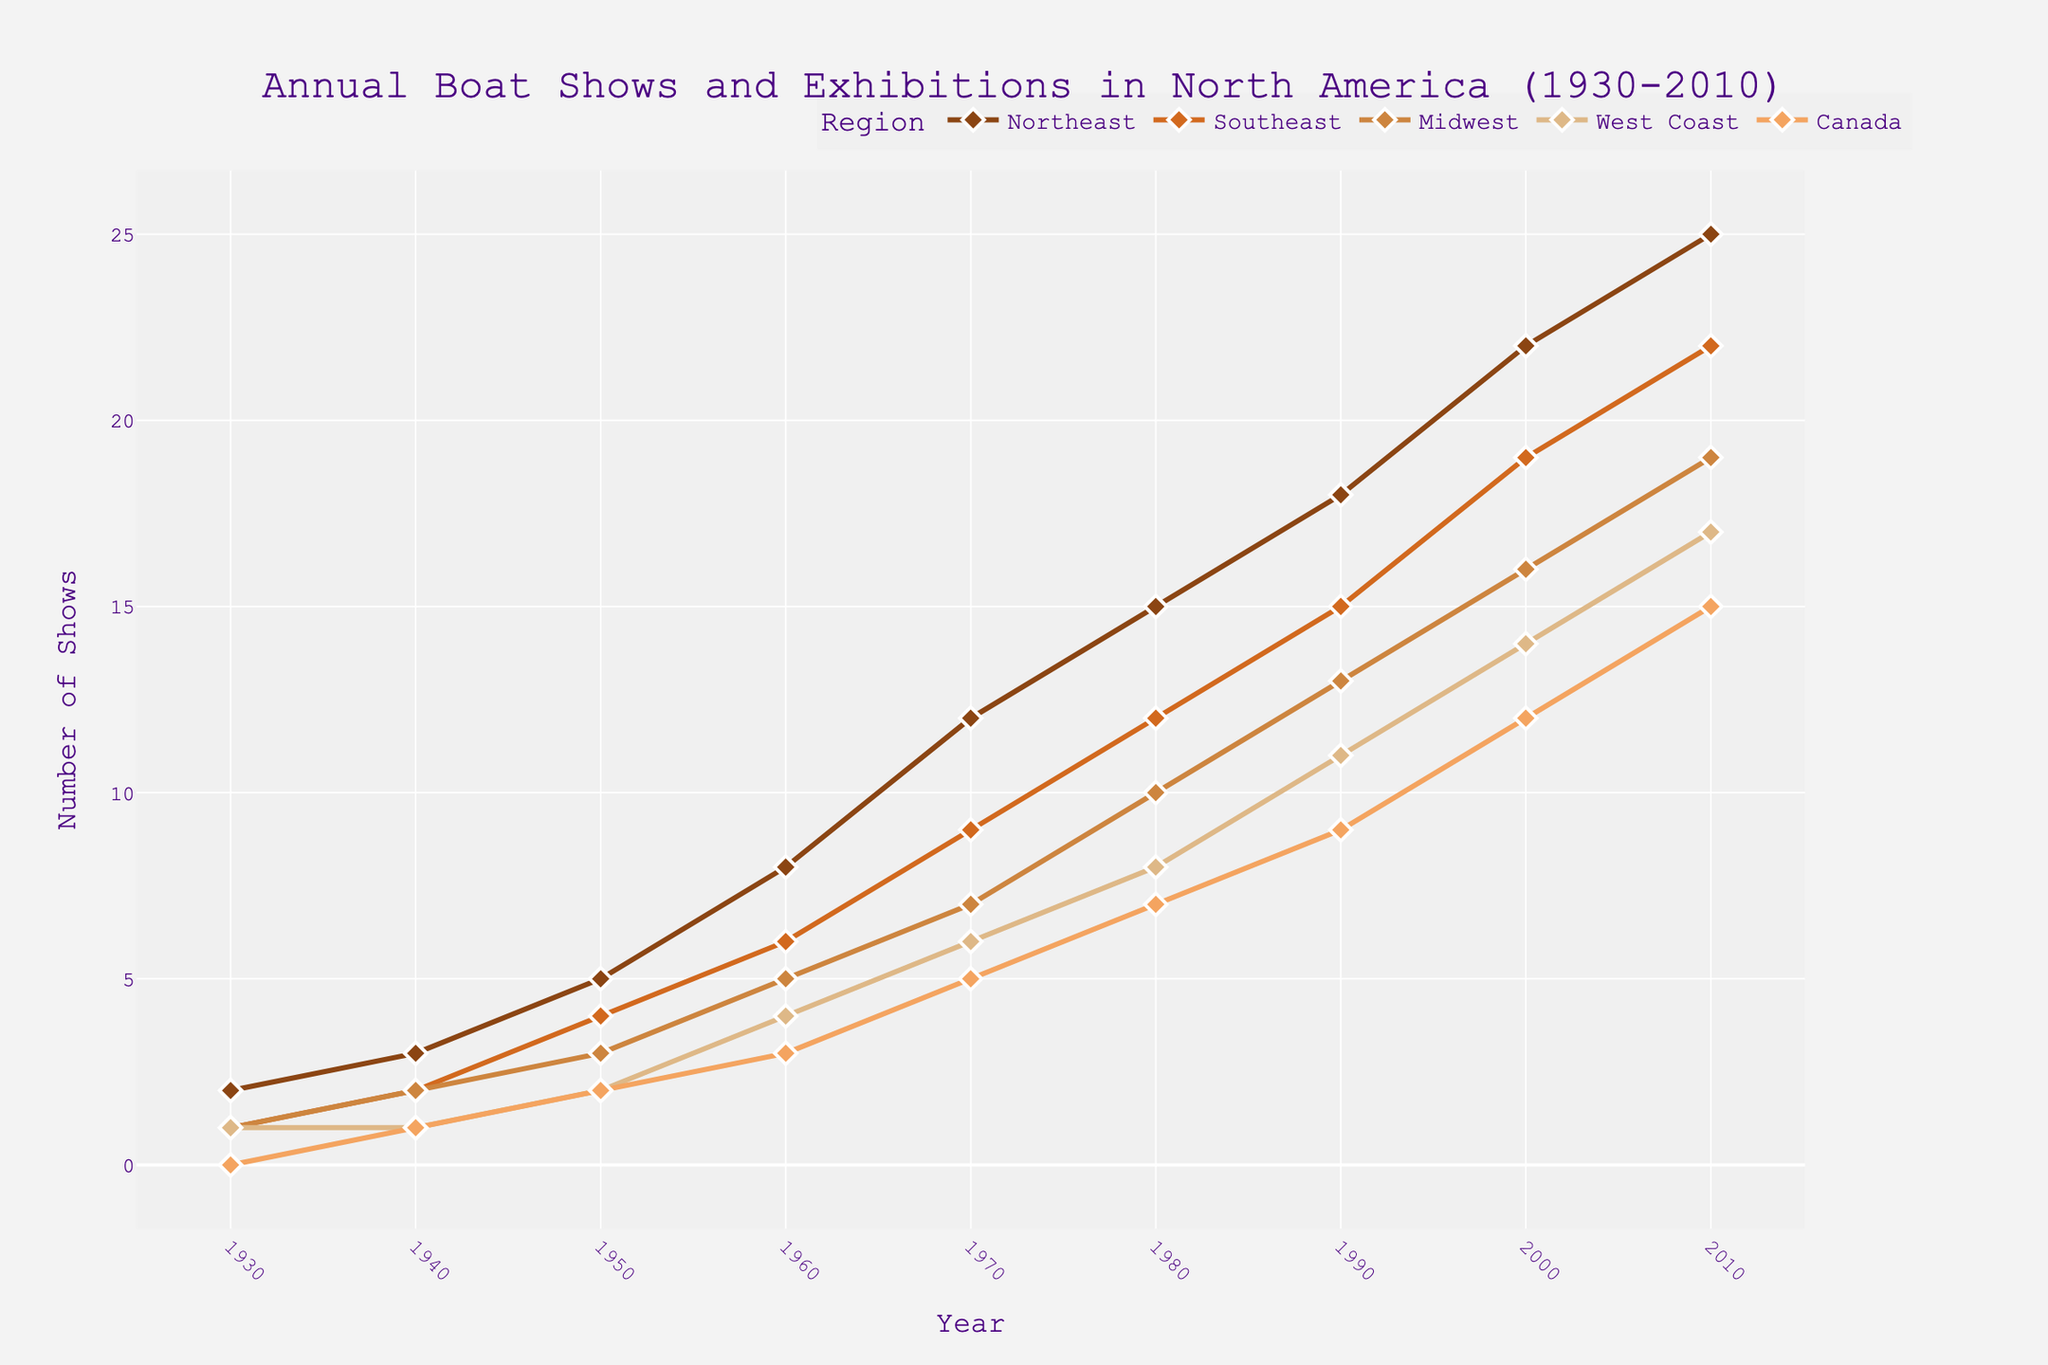How many shows were held in Canada in 1980 and what is the difference compared to 1990? In 1980, Canada held 7 shows. In 1990, Canada held 9 shows. The difference is 9 - 7 = 2.
Answer: 2 Which region had the highest number of shows in 1970 and how many were there? The Northeast had the highest number of shows in 1970, with 12 shows.
Answer: Northeast, 12 What was the trend in the number of shows in the Midwest region between 1960 and 2000? In the Midwest, the number of shows consistently increased: 5 in 1960, 7 in 1970, 10 in 1980, 13 in 1990, and 16 in 2000.
Answer: Increased Which year had the smallest total number of shows across all regions combined? Adding the numbers for each year, 1930 has the smallest total: 2 + 1 + 1 + 1 + 0 = 5.
Answer: 1930 How does the number of shows in the Southeast in 1950 compare to the number in the Northeast in the same year? In 1950, the Southeast had 4 shows, and the Northeast had 5 shows. So the Southeast had 1 show less than the Northeast.
Answer: 1 less What is the average number of shows in the West Coast region between 1990 and 2010? The numbers for the West Coast in 1990, 2000, and 2010 are 11, 14, and 17 respectively. The average is (11 + 14 + 17)/3 = 14.
Answer: 14 Which year saw the largest increase in shows for the Northeast from the previous decade? The largest increase is from 1940 to 1950. The number of shows in the Northeast increased from 3 to 5.
Answer: 1940 to 1950 What is the color used to represent the Midwest region? The plot uses brown shades for different regions. The Midwest is represented by a tan-like color.
Answer: Tan-like color In 2000, which region had the second-highest number of shows? In 2000, the Northeast had 22 shows, the Southeast had 19 shows, the Midwest had 16 shows, the West Coast had 14 shows, and Canada had 12 shows. The Southeast had the second-highest number after the Northeast.
Answer: Southeast 